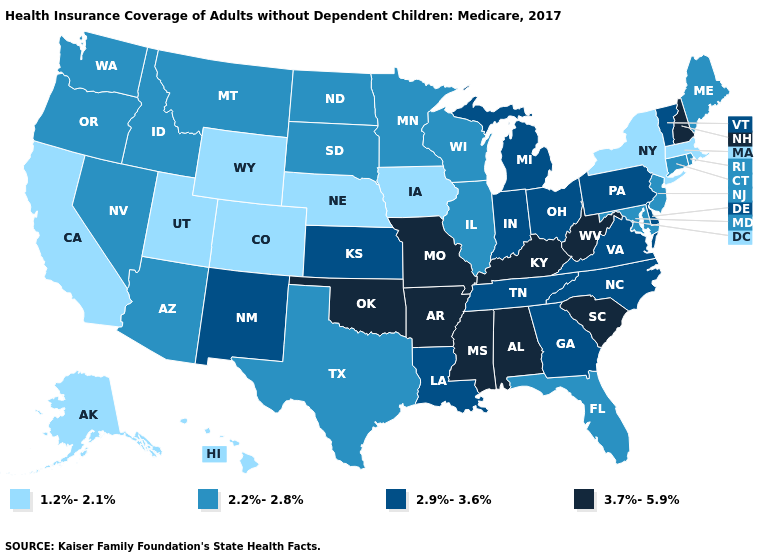Does Minnesota have the highest value in the MidWest?
Be succinct. No. Name the states that have a value in the range 1.2%-2.1%?
Give a very brief answer. Alaska, California, Colorado, Hawaii, Iowa, Massachusetts, Nebraska, New York, Utah, Wyoming. What is the value of South Carolina?
Write a very short answer. 3.7%-5.9%. Among the states that border Arkansas , does Louisiana have the highest value?
Concise answer only. No. Does Vermont have the lowest value in the Northeast?
Write a very short answer. No. Is the legend a continuous bar?
Answer briefly. No. Does the map have missing data?
Concise answer only. No. Which states have the lowest value in the USA?
Quick response, please. Alaska, California, Colorado, Hawaii, Iowa, Massachusetts, Nebraska, New York, Utah, Wyoming. Does Vermont have a higher value than South Dakota?
Answer briefly. Yes. Name the states that have a value in the range 2.9%-3.6%?
Concise answer only. Delaware, Georgia, Indiana, Kansas, Louisiana, Michigan, New Mexico, North Carolina, Ohio, Pennsylvania, Tennessee, Vermont, Virginia. What is the value of Maine?
Answer briefly. 2.2%-2.8%. Which states have the lowest value in the West?
Short answer required. Alaska, California, Colorado, Hawaii, Utah, Wyoming. How many symbols are there in the legend?
Short answer required. 4. Does the first symbol in the legend represent the smallest category?
Answer briefly. Yes. What is the highest value in the Northeast ?
Quick response, please. 3.7%-5.9%. 